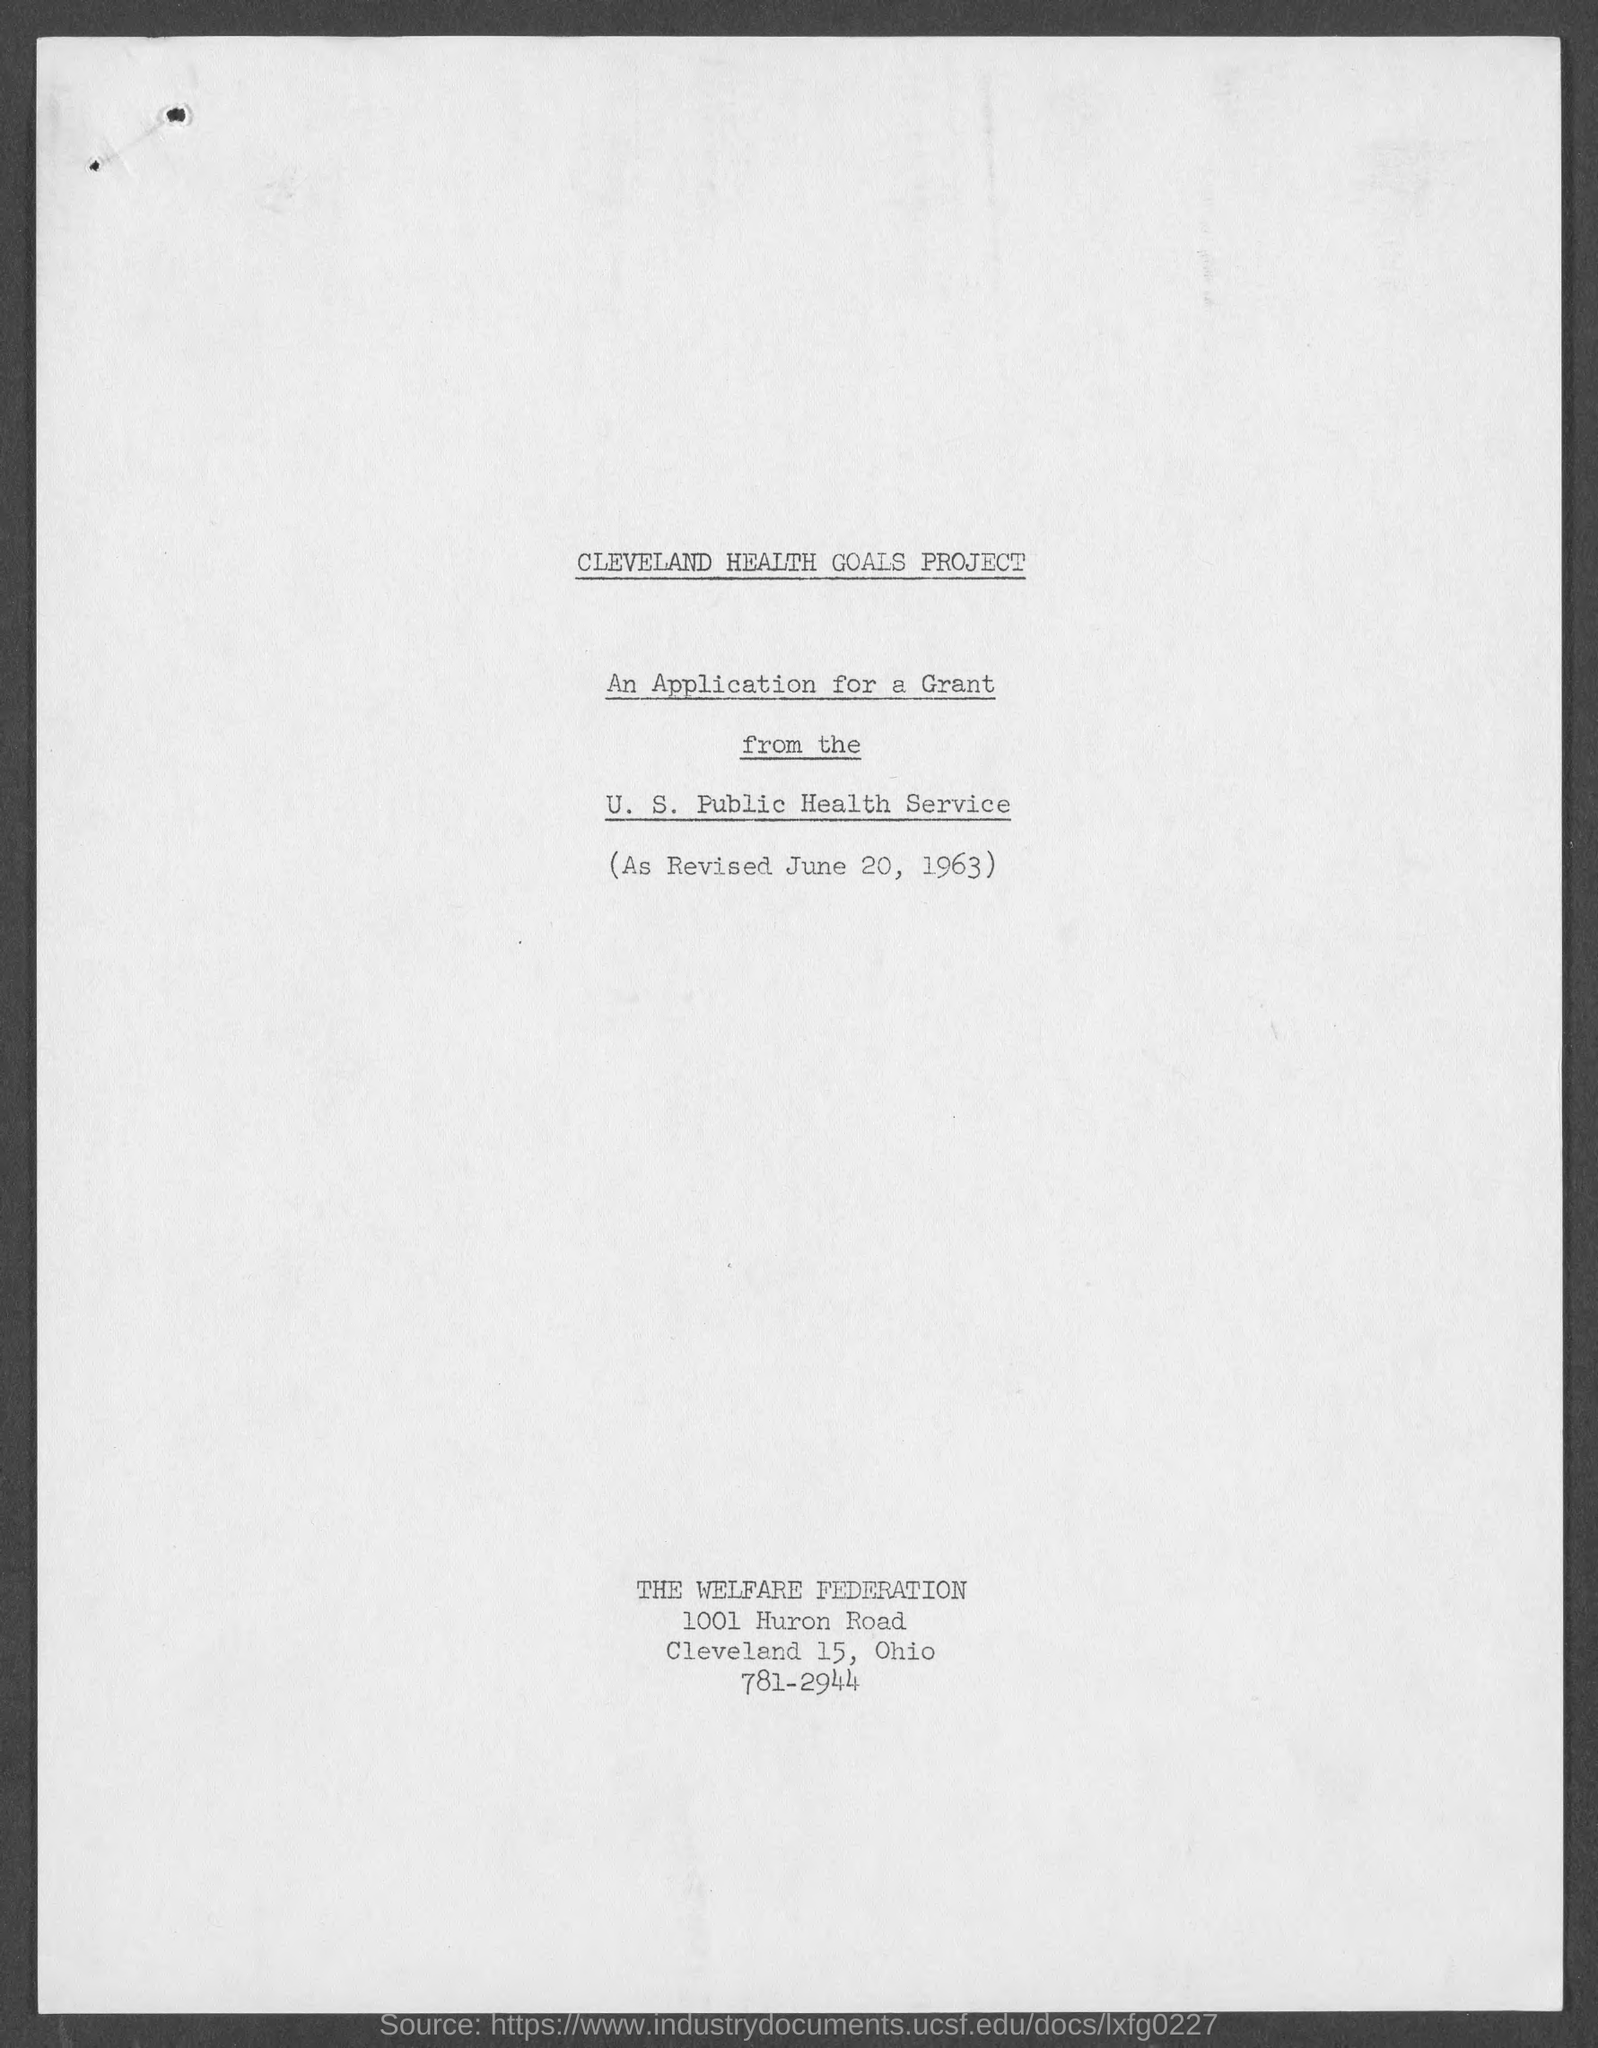Identify some key points in this picture. The date of revision is June 20, 1963. 